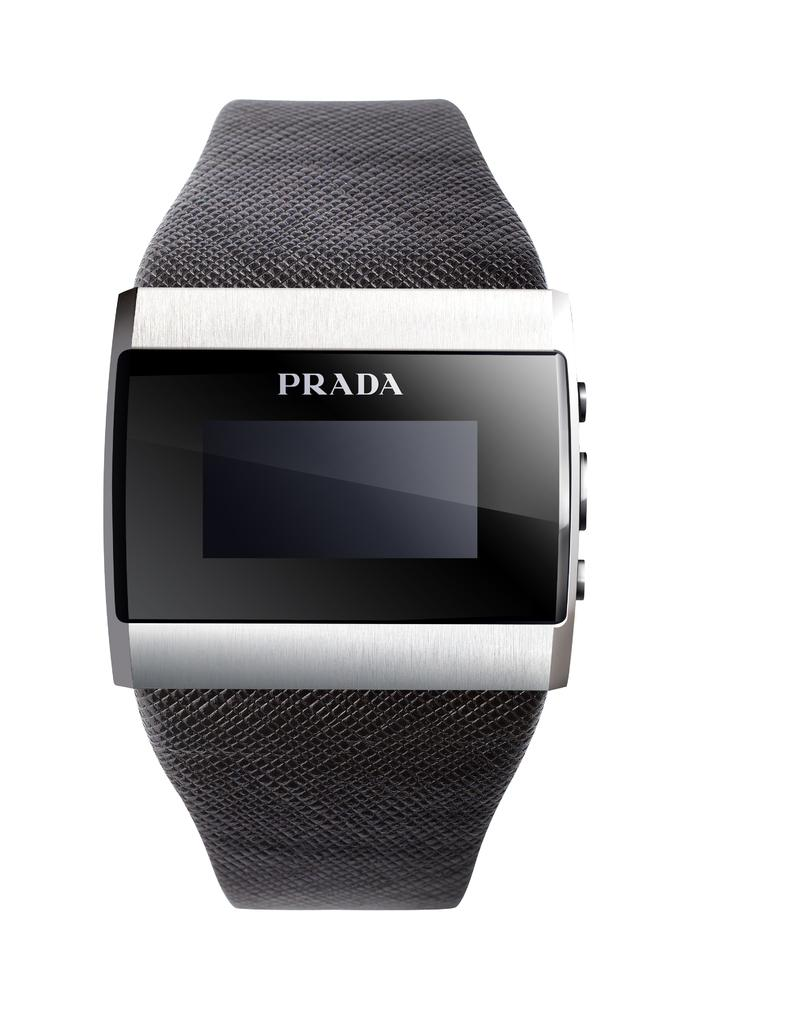Provide a one-sentence caption for the provided image. Black and silver Prada watch with a square screen. 